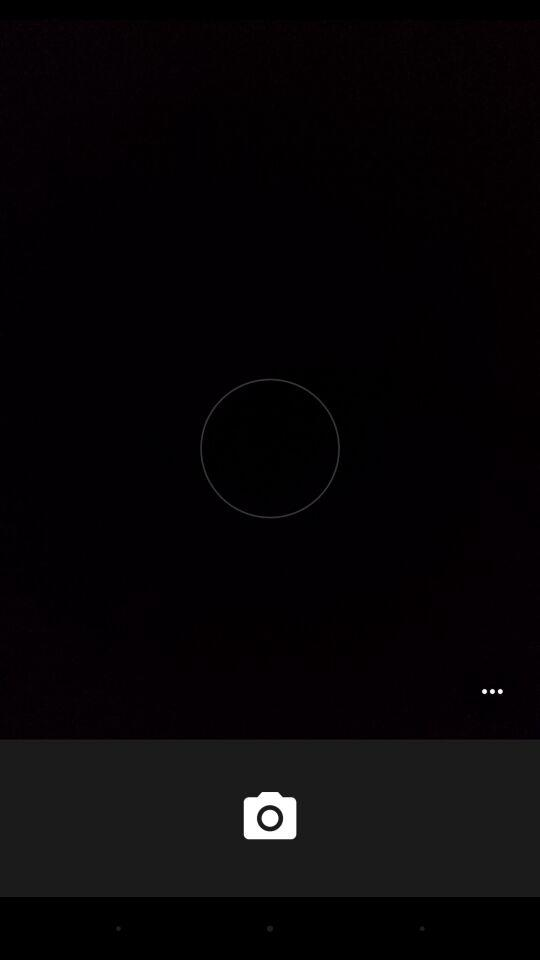How many more dots are there than cameras?
Answer the question using a single word or phrase. 2 